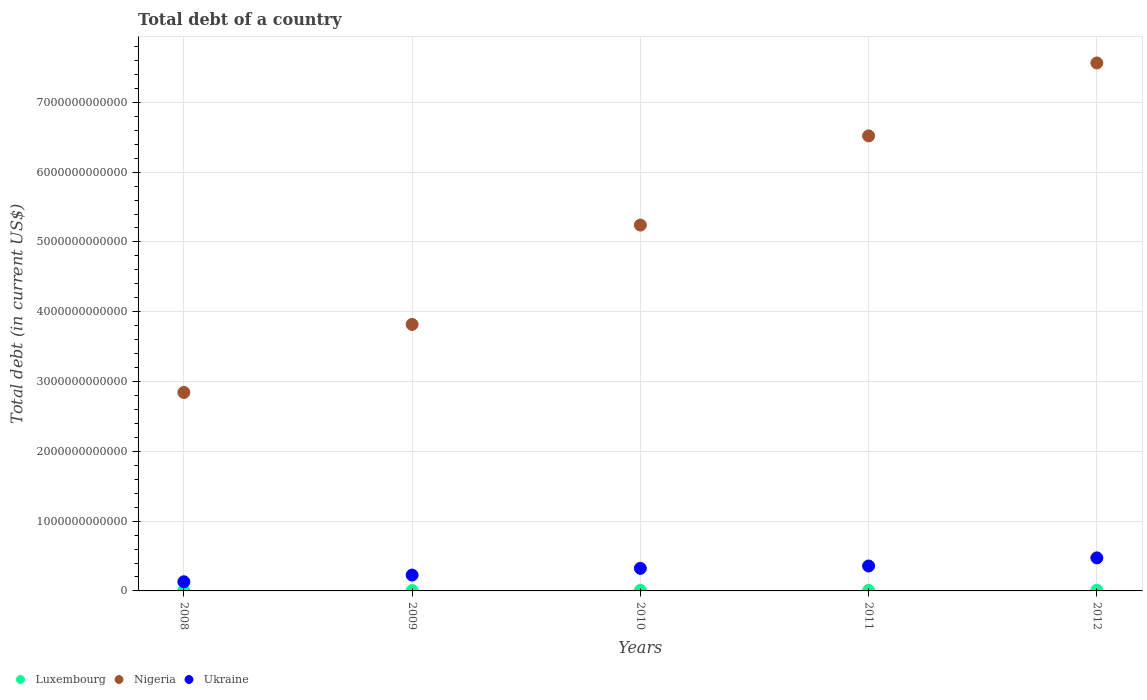How many different coloured dotlines are there?
Offer a very short reply. 3. What is the debt in Ukraine in 2009?
Ensure brevity in your answer.  2.27e+11. Across all years, what is the maximum debt in Luxembourg?
Ensure brevity in your answer.  8.78e+09. Across all years, what is the minimum debt in Luxembourg?
Give a very brief answer. 4.63e+09. In which year was the debt in Nigeria minimum?
Provide a succinct answer. 2008. What is the total debt in Nigeria in the graph?
Provide a short and direct response. 2.60e+13. What is the difference between the debt in Nigeria in 2008 and that in 2009?
Provide a succinct answer. -9.75e+11. What is the difference between the debt in Luxembourg in 2009 and the debt in Ukraine in 2010?
Your response must be concise. -3.19e+11. What is the average debt in Ukraine per year?
Provide a short and direct response. 3.02e+11. In the year 2010, what is the difference between the debt in Ukraine and debt in Luxembourg?
Ensure brevity in your answer.  3.17e+11. In how many years, is the debt in Nigeria greater than 5400000000000 US$?
Your answer should be very brief. 2. What is the ratio of the debt in Nigeria in 2008 to that in 2009?
Your answer should be compact. 0.74. Is the debt in Luxembourg in 2009 less than that in 2011?
Make the answer very short. Yes. Is the difference between the debt in Ukraine in 2010 and 2012 greater than the difference between the debt in Luxembourg in 2010 and 2012?
Keep it short and to the point. No. What is the difference between the highest and the second highest debt in Luxembourg?
Provide a succinct answer. 1.60e+09. What is the difference between the highest and the lowest debt in Luxembourg?
Provide a succinct answer. 4.15e+09. In how many years, is the debt in Nigeria greater than the average debt in Nigeria taken over all years?
Keep it short and to the point. 3. Does the debt in Ukraine monotonically increase over the years?
Give a very brief answer. Yes. Is the debt in Nigeria strictly greater than the debt in Luxembourg over the years?
Offer a terse response. Yes. How many years are there in the graph?
Your response must be concise. 5. What is the difference between two consecutive major ticks on the Y-axis?
Give a very brief answer. 1.00e+12. Does the graph contain any zero values?
Ensure brevity in your answer.  No. Where does the legend appear in the graph?
Keep it short and to the point. Bottom left. How many legend labels are there?
Keep it short and to the point. 3. How are the legend labels stacked?
Provide a short and direct response. Horizontal. What is the title of the graph?
Your answer should be very brief. Total debt of a country. What is the label or title of the Y-axis?
Make the answer very short. Total debt (in current US$). What is the Total debt (in current US$) of Luxembourg in 2008?
Make the answer very short. 4.63e+09. What is the Total debt (in current US$) in Nigeria in 2008?
Offer a terse response. 2.84e+12. What is the Total debt (in current US$) of Ukraine in 2008?
Keep it short and to the point. 1.31e+11. What is the Total debt (in current US$) in Luxembourg in 2009?
Your response must be concise. 4.80e+09. What is the Total debt (in current US$) of Nigeria in 2009?
Provide a short and direct response. 3.82e+12. What is the Total debt (in current US$) in Ukraine in 2009?
Make the answer very short. 2.27e+11. What is the Total debt (in current US$) in Luxembourg in 2010?
Keep it short and to the point. 6.89e+09. What is the Total debt (in current US$) of Nigeria in 2010?
Ensure brevity in your answer.  5.24e+12. What is the Total debt (in current US$) in Ukraine in 2010?
Ensure brevity in your answer.  3.23e+11. What is the Total debt (in current US$) of Luxembourg in 2011?
Your response must be concise. 7.18e+09. What is the Total debt (in current US$) in Nigeria in 2011?
Your response must be concise. 6.52e+12. What is the Total debt (in current US$) in Ukraine in 2011?
Provide a succinct answer. 3.57e+11. What is the Total debt (in current US$) of Luxembourg in 2012?
Your answer should be compact. 8.78e+09. What is the Total debt (in current US$) in Nigeria in 2012?
Ensure brevity in your answer.  7.56e+12. What is the Total debt (in current US$) in Ukraine in 2012?
Your answer should be compact. 4.73e+11. Across all years, what is the maximum Total debt (in current US$) in Luxembourg?
Ensure brevity in your answer.  8.78e+09. Across all years, what is the maximum Total debt (in current US$) of Nigeria?
Provide a short and direct response. 7.56e+12. Across all years, what is the maximum Total debt (in current US$) of Ukraine?
Offer a very short reply. 4.73e+11. Across all years, what is the minimum Total debt (in current US$) in Luxembourg?
Keep it short and to the point. 4.63e+09. Across all years, what is the minimum Total debt (in current US$) in Nigeria?
Provide a short and direct response. 2.84e+12. Across all years, what is the minimum Total debt (in current US$) of Ukraine?
Keep it short and to the point. 1.31e+11. What is the total Total debt (in current US$) in Luxembourg in the graph?
Keep it short and to the point. 3.23e+1. What is the total Total debt (in current US$) in Nigeria in the graph?
Make the answer very short. 2.60e+13. What is the total Total debt (in current US$) in Ukraine in the graph?
Keep it short and to the point. 1.51e+12. What is the difference between the Total debt (in current US$) of Luxembourg in 2008 and that in 2009?
Provide a short and direct response. -1.70e+08. What is the difference between the Total debt (in current US$) of Nigeria in 2008 and that in 2009?
Ensure brevity in your answer.  -9.75e+11. What is the difference between the Total debt (in current US$) in Ukraine in 2008 and that in 2009?
Your answer should be compact. -9.61e+1. What is the difference between the Total debt (in current US$) of Luxembourg in 2008 and that in 2010?
Keep it short and to the point. -2.27e+09. What is the difference between the Total debt (in current US$) in Nigeria in 2008 and that in 2010?
Your answer should be compact. -2.40e+12. What is the difference between the Total debt (in current US$) in Ukraine in 2008 and that in 2010?
Your response must be concise. -1.92e+11. What is the difference between the Total debt (in current US$) of Luxembourg in 2008 and that in 2011?
Offer a terse response. -2.55e+09. What is the difference between the Total debt (in current US$) of Nigeria in 2008 and that in 2011?
Provide a short and direct response. -3.68e+12. What is the difference between the Total debt (in current US$) of Ukraine in 2008 and that in 2011?
Your answer should be very brief. -2.26e+11. What is the difference between the Total debt (in current US$) of Luxembourg in 2008 and that in 2012?
Ensure brevity in your answer.  -4.15e+09. What is the difference between the Total debt (in current US$) of Nigeria in 2008 and that in 2012?
Provide a succinct answer. -4.72e+12. What is the difference between the Total debt (in current US$) in Ukraine in 2008 and that in 2012?
Provide a succinct answer. -3.42e+11. What is the difference between the Total debt (in current US$) of Luxembourg in 2009 and that in 2010?
Your response must be concise. -2.10e+09. What is the difference between the Total debt (in current US$) of Nigeria in 2009 and that in 2010?
Provide a short and direct response. -1.42e+12. What is the difference between the Total debt (in current US$) in Ukraine in 2009 and that in 2010?
Give a very brief answer. -9.63e+1. What is the difference between the Total debt (in current US$) in Luxembourg in 2009 and that in 2011?
Make the answer very short. -2.38e+09. What is the difference between the Total debt (in current US$) in Nigeria in 2009 and that in 2011?
Your answer should be very brief. -2.70e+12. What is the difference between the Total debt (in current US$) of Ukraine in 2009 and that in 2011?
Ensure brevity in your answer.  -1.30e+11. What is the difference between the Total debt (in current US$) in Luxembourg in 2009 and that in 2012?
Ensure brevity in your answer.  -3.98e+09. What is the difference between the Total debt (in current US$) in Nigeria in 2009 and that in 2012?
Make the answer very short. -3.75e+12. What is the difference between the Total debt (in current US$) of Ukraine in 2009 and that in 2012?
Make the answer very short. -2.46e+11. What is the difference between the Total debt (in current US$) of Luxembourg in 2010 and that in 2011?
Provide a short and direct response. -2.83e+08. What is the difference between the Total debt (in current US$) in Nigeria in 2010 and that in 2011?
Keep it short and to the point. -1.28e+12. What is the difference between the Total debt (in current US$) of Ukraine in 2010 and that in 2011?
Offer a terse response. -3.38e+1. What is the difference between the Total debt (in current US$) of Luxembourg in 2010 and that in 2012?
Your answer should be very brief. -1.88e+09. What is the difference between the Total debt (in current US$) in Nigeria in 2010 and that in 2012?
Offer a terse response. -2.32e+12. What is the difference between the Total debt (in current US$) in Ukraine in 2010 and that in 2012?
Your response must be concise. -1.50e+11. What is the difference between the Total debt (in current US$) of Luxembourg in 2011 and that in 2012?
Keep it short and to the point. -1.60e+09. What is the difference between the Total debt (in current US$) of Nigeria in 2011 and that in 2012?
Make the answer very short. -1.04e+12. What is the difference between the Total debt (in current US$) of Ukraine in 2011 and that in 2012?
Provide a short and direct response. -1.16e+11. What is the difference between the Total debt (in current US$) of Luxembourg in 2008 and the Total debt (in current US$) of Nigeria in 2009?
Ensure brevity in your answer.  -3.81e+12. What is the difference between the Total debt (in current US$) in Luxembourg in 2008 and the Total debt (in current US$) in Ukraine in 2009?
Offer a very short reply. -2.23e+11. What is the difference between the Total debt (in current US$) in Nigeria in 2008 and the Total debt (in current US$) in Ukraine in 2009?
Offer a terse response. 2.62e+12. What is the difference between the Total debt (in current US$) of Luxembourg in 2008 and the Total debt (in current US$) of Nigeria in 2010?
Keep it short and to the point. -5.24e+12. What is the difference between the Total debt (in current US$) of Luxembourg in 2008 and the Total debt (in current US$) of Ukraine in 2010?
Your response must be concise. -3.19e+11. What is the difference between the Total debt (in current US$) in Nigeria in 2008 and the Total debt (in current US$) in Ukraine in 2010?
Offer a very short reply. 2.52e+12. What is the difference between the Total debt (in current US$) of Luxembourg in 2008 and the Total debt (in current US$) of Nigeria in 2011?
Provide a short and direct response. -6.51e+12. What is the difference between the Total debt (in current US$) of Luxembourg in 2008 and the Total debt (in current US$) of Ukraine in 2011?
Make the answer very short. -3.53e+11. What is the difference between the Total debt (in current US$) in Nigeria in 2008 and the Total debt (in current US$) in Ukraine in 2011?
Your answer should be very brief. 2.49e+12. What is the difference between the Total debt (in current US$) in Luxembourg in 2008 and the Total debt (in current US$) in Nigeria in 2012?
Offer a terse response. -7.56e+12. What is the difference between the Total debt (in current US$) of Luxembourg in 2008 and the Total debt (in current US$) of Ukraine in 2012?
Your answer should be very brief. -4.69e+11. What is the difference between the Total debt (in current US$) in Nigeria in 2008 and the Total debt (in current US$) in Ukraine in 2012?
Offer a terse response. 2.37e+12. What is the difference between the Total debt (in current US$) of Luxembourg in 2009 and the Total debt (in current US$) of Nigeria in 2010?
Ensure brevity in your answer.  -5.24e+12. What is the difference between the Total debt (in current US$) in Luxembourg in 2009 and the Total debt (in current US$) in Ukraine in 2010?
Ensure brevity in your answer.  -3.19e+11. What is the difference between the Total debt (in current US$) of Nigeria in 2009 and the Total debt (in current US$) of Ukraine in 2010?
Your answer should be very brief. 3.49e+12. What is the difference between the Total debt (in current US$) in Luxembourg in 2009 and the Total debt (in current US$) in Nigeria in 2011?
Offer a terse response. -6.51e+12. What is the difference between the Total debt (in current US$) in Luxembourg in 2009 and the Total debt (in current US$) in Ukraine in 2011?
Keep it short and to the point. -3.52e+11. What is the difference between the Total debt (in current US$) in Nigeria in 2009 and the Total debt (in current US$) in Ukraine in 2011?
Offer a very short reply. 3.46e+12. What is the difference between the Total debt (in current US$) of Luxembourg in 2009 and the Total debt (in current US$) of Nigeria in 2012?
Provide a short and direct response. -7.56e+12. What is the difference between the Total debt (in current US$) in Luxembourg in 2009 and the Total debt (in current US$) in Ukraine in 2012?
Give a very brief answer. -4.69e+11. What is the difference between the Total debt (in current US$) of Nigeria in 2009 and the Total debt (in current US$) of Ukraine in 2012?
Your answer should be very brief. 3.34e+12. What is the difference between the Total debt (in current US$) of Luxembourg in 2010 and the Total debt (in current US$) of Nigeria in 2011?
Your response must be concise. -6.51e+12. What is the difference between the Total debt (in current US$) in Luxembourg in 2010 and the Total debt (in current US$) in Ukraine in 2011?
Your response must be concise. -3.50e+11. What is the difference between the Total debt (in current US$) in Nigeria in 2010 and the Total debt (in current US$) in Ukraine in 2011?
Your answer should be very brief. 4.88e+12. What is the difference between the Total debt (in current US$) of Luxembourg in 2010 and the Total debt (in current US$) of Nigeria in 2012?
Your answer should be compact. -7.56e+12. What is the difference between the Total debt (in current US$) of Luxembourg in 2010 and the Total debt (in current US$) of Ukraine in 2012?
Keep it short and to the point. -4.67e+11. What is the difference between the Total debt (in current US$) of Nigeria in 2010 and the Total debt (in current US$) of Ukraine in 2012?
Make the answer very short. 4.77e+12. What is the difference between the Total debt (in current US$) in Luxembourg in 2011 and the Total debt (in current US$) in Nigeria in 2012?
Offer a very short reply. -7.56e+12. What is the difference between the Total debt (in current US$) in Luxembourg in 2011 and the Total debt (in current US$) in Ukraine in 2012?
Offer a very short reply. -4.66e+11. What is the difference between the Total debt (in current US$) in Nigeria in 2011 and the Total debt (in current US$) in Ukraine in 2012?
Make the answer very short. 6.05e+12. What is the average Total debt (in current US$) in Luxembourg per year?
Make the answer very short. 6.46e+09. What is the average Total debt (in current US$) in Nigeria per year?
Provide a succinct answer. 5.20e+12. What is the average Total debt (in current US$) of Ukraine per year?
Your answer should be compact. 3.02e+11. In the year 2008, what is the difference between the Total debt (in current US$) in Luxembourg and Total debt (in current US$) in Nigeria?
Keep it short and to the point. -2.84e+12. In the year 2008, what is the difference between the Total debt (in current US$) of Luxembourg and Total debt (in current US$) of Ukraine?
Provide a short and direct response. -1.26e+11. In the year 2008, what is the difference between the Total debt (in current US$) of Nigeria and Total debt (in current US$) of Ukraine?
Make the answer very short. 2.71e+12. In the year 2009, what is the difference between the Total debt (in current US$) in Luxembourg and Total debt (in current US$) in Nigeria?
Give a very brief answer. -3.81e+12. In the year 2009, what is the difference between the Total debt (in current US$) in Luxembourg and Total debt (in current US$) in Ukraine?
Your answer should be compact. -2.22e+11. In the year 2009, what is the difference between the Total debt (in current US$) of Nigeria and Total debt (in current US$) of Ukraine?
Your answer should be compact. 3.59e+12. In the year 2010, what is the difference between the Total debt (in current US$) in Luxembourg and Total debt (in current US$) in Nigeria?
Make the answer very short. -5.23e+12. In the year 2010, what is the difference between the Total debt (in current US$) in Luxembourg and Total debt (in current US$) in Ukraine?
Your answer should be very brief. -3.17e+11. In the year 2010, what is the difference between the Total debt (in current US$) of Nigeria and Total debt (in current US$) of Ukraine?
Offer a very short reply. 4.92e+12. In the year 2011, what is the difference between the Total debt (in current US$) in Luxembourg and Total debt (in current US$) in Nigeria?
Ensure brevity in your answer.  -6.51e+12. In the year 2011, what is the difference between the Total debt (in current US$) in Luxembourg and Total debt (in current US$) in Ukraine?
Provide a short and direct response. -3.50e+11. In the year 2011, what is the difference between the Total debt (in current US$) of Nigeria and Total debt (in current US$) of Ukraine?
Your answer should be very brief. 6.16e+12. In the year 2012, what is the difference between the Total debt (in current US$) in Luxembourg and Total debt (in current US$) in Nigeria?
Make the answer very short. -7.56e+12. In the year 2012, what is the difference between the Total debt (in current US$) of Luxembourg and Total debt (in current US$) of Ukraine?
Your answer should be compact. -4.65e+11. In the year 2012, what is the difference between the Total debt (in current US$) of Nigeria and Total debt (in current US$) of Ukraine?
Your answer should be very brief. 7.09e+12. What is the ratio of the Total debt (in current US$) of Luxembourg in 2008 to that in 2009?
Your answer should be very brief. 0.96. What is the ratio of the Total debt (in current US$) of Nigeria in 2008 to that in 2009?
Keep it short and to the point. 0.74. What is the ratio of the Total debt (in current US$) of Ukraine in 2008 to that in 2009?
Provide a succinct answer. 0.58. What is the ratio of the Total debt (in current US$) in Luxembourg in 2008 to that in 2010?
Your answer should be very brief. 0.67. What is the ratio of the Total debt (in current US$) of Nigeria in 2008 to that in 2010?
Make the answer very short. 0.54. What is the ratio of the Total debt (in current US$) of Ukraine in 2008 to that in 2010?
Make the answer very short. 0.41. What is the ratio of the Total debt (in current US$) of Luxembourg in 2008 to that in 2011?
Provide a succinct answer. 0.64. What is the ratio of the Total debt (in current US$) in Nigeria in 2008 to that in 2011?
Keep it short and to the point. 0.44. What is the ratio of the Total debt (in current US$) in Ukraine in 2008 to that in 2011?
Ensure brevity in your answer.  0.37. What is the ratio of the Total debt (in current US$) in Luxembourg in 2008 to that in 2012?
Ensure brevity in your answer.  0.53. What is the ratio of the Total debt (in current US$) in Nigeria in 2008 to that in 2012?
Keep it short and to the point. 0.38. What is the ratio of the Total debt (in current US$) in Ukraine in 2008 to that in 2012?
Provide a short and direct response. 0.28. What is the ratio of the Total debt (in current US$) of Luxembourg in 2009 to that in 2010?
Offer a terse response. 0.7. What is the ratio of the Total debt (in current US$) of Nigeria in 2009 to that in 2010?
Provide a short and direct response. 0.73. What is the ratio of the Total debt (in current US$) of Ukraine in 2009 to that in 2010?
Your response must be concise. 0.7. What is the ratio of the Total debt (in current US$) in Luxembourg in 2009 to that in 2011?
Provide a short and direct response. 0.67. What is the ratio of the Total debt (in current US$) of Nigeria in 2009 to that in 2011?
Your answer should be very brief. 0.59. What is the ratio of the Total debt (in current US$) in Ukraine in 2009 to that in 2011?
Offer a terse response. 0.64. What is the ratio of the Total debt (in current US$) of Luxembourg in 2009 to that in 2012?
Offer a terse response. 0.55. What is the ratio of the Total debt (in current US$) of Nigeria in 2009 to that in 2012?
Provide a succinct answer. 0.5. What is the ratio of the Total debt (in current US$) in Ukraine in 2009 to that in 2012?
Your response must be concise. 0.48. What is the ratio of the Total debt (in current US$) of Luxembourg in 2010 to that in 2011?
Provide a short and direct response. 0.96. What is the ratio of the Total debt (in current US$) in Nigeria in 2010 to that in 2011?
Keep it short and to the point. 0.8. What is the ratio of the Total debt (in current US$) in Ukraine in 2010 to that in 2011?
Offer a terse response. 0.91. What is the ratio of the Total debt (in current US$) of Luxembourg in 2010 to that in 2012?
Offer a terse response. 0.79. What is the ratio of the Total debt (in current US$) of Nigeria in 2010 to that in 2012?
Your response must be concise. 0.69. What is the ratio of the Total debt (in current US$) in Ukraine in 2010 to that in 2012?
Your answer should be very brief. 0.68. What is the ratio of the Total debt (in current US$) in Luxembourg in 2011 to that in 2012?
Make the answer very short. 0.82. What is the ratio of the Total debt (in current US$) in Nigeria in 2011 to that in 2012?
Your response must be concise. 0.86. What is the ratio of the Total debt (in current US$) in Ukraine in 2011 to that in 2012?
Offer a very short reply. 0.75. What is the difference between the highest and the second highest Total debt (in current US$) in Luxembourg?
Keep it short and to the point. 1.60e+09. What is the difference between the highest and the second highest Total debt (in current US$) in Nigeria?
Give a very brief answer. 1.04e+12. What is the difference between the highest and the second highest Total debt (in current US$) in Ukraine?
Keep it short and to the point. 1.16e+11. What is the difference between the highest and the lowest Total debt (in current US$) of Luxembourg?
Your answer should be very brief. 4.15e+09. What is the difference between the highest and the lowest Total debt (in current US$) of Nigeria?
Keep it short and to the point. 4.72e+12. What is the difference between the highest and the lowest Total debt (in current US$) in Ukraine?
Your answer should be very brief. 3.42e+11. 